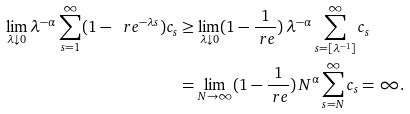<formula> <loc_0><loc_0><loc_500><loc_500>\lim _ { \lambda \downarrow 0 } \lambda ^ { - \alpha } \sum _ { s = 1 } ^ { \infty } ( 1 - \ r e ^ { - \lambda s } ) c _ { s } & \geq \lim _ { \lambda \downarrow 0 } ( 1 - \frac { 1 } { \ r e } ) \, \lambda ^ { - \alpha } \sum _ { s = [ \lambda ^ { - 1 } ] } ^ { \infty } c _ { s } \\ & = \lim _ { N \to \infty } ( 1 - \frac { 1 } { \ r e } ) \, N ^ { \alpha } \sum _ { s = N } ^ { \infty } c _ { s } = \infty .</formula> 